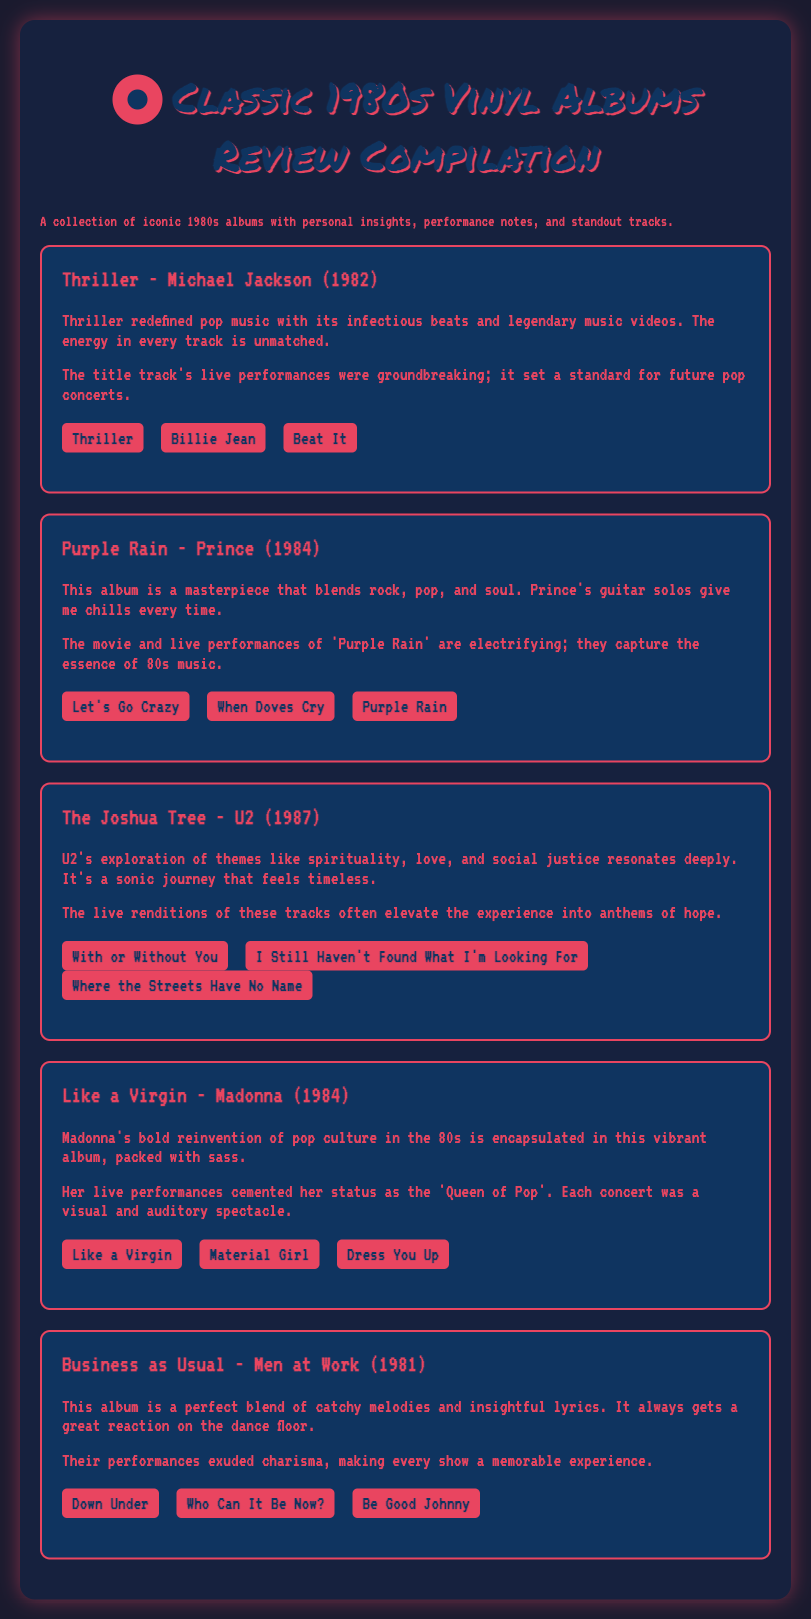What is the title of the document? The title of the document is found in the header section and describes the compilation of reviews for classic 1980s vinyl albums.
Answer: Classic 1980s Vinyl Albums Review Compilation Who is the artist of the album "Purple Rain"? The artist associated with the album "Purple Rain" can be found under the corresponding album section in the document.
Answer: Prince In what year was "Thriller" released? The year of release for "Thriller" is provided in the album title section of the document.
Answer: 1982 What standout track is listed for U2's album? The standout tracks for each album can be found in their respective sections; "With or Without You" is one of the tracks listed for U2.
Answer: With or Without You Which album's standout tracks include "Material Girl"? The album that features the standout track "Material Girl" can be located in the section related to Madonna.
Answer: Like a Virgin What theme does U2 explore in The Joshua Tree? The themes explored in U2's album The Joshua Tree are mentioned in the thoughts section of the review.
Answer: Spirituality, love, and social justice How does the document describe Madonna's impact on pop culture? The document outlines Madonna's contributions to pop culture in the thoughts section of her album review, emphasizing her boldness.
Answer: Bold reinvention Which album is noted for its catchy melodies and insightful lyrics? The album known for catchy melodies and insightful lyrics is mentioned in the thoughts section of Men at Work's review.
Answer: Business as Usual What performance style is highlighted for "Thriller"? The performance style of the title track is noted in the notes section of the "Thriller" review.
Answer: Groundbreaking 